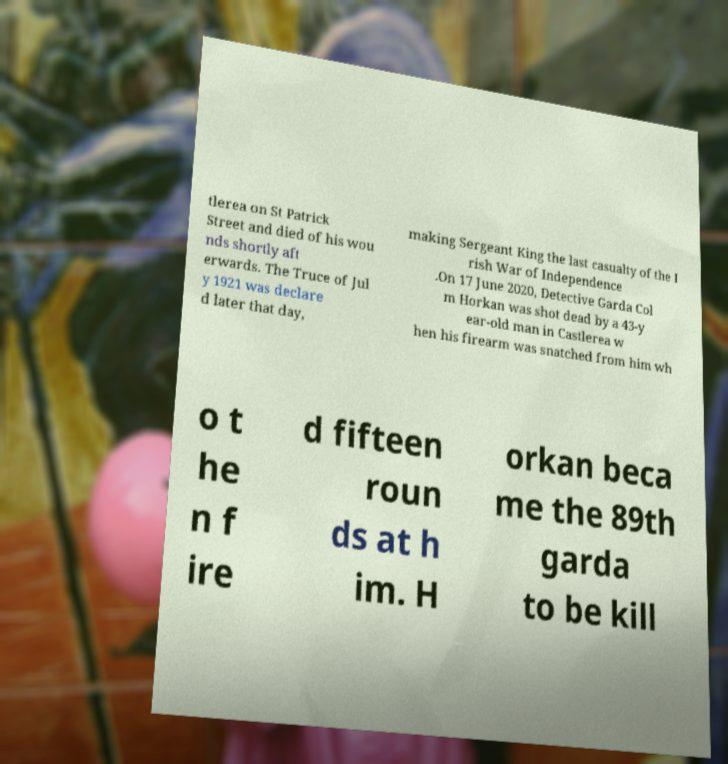Can you accurately transcribe the text from the provided image for me? tlerea on St Patrick Street and died of his wou nds shortly aft erwards. The Truce of Jul y 1921 was declare d later that day, making Sergeant King the last casualty of the I rish War of Independence .On 17 June 2020, Detective Garda Col m Horkan was shot dead by a 43-y ear-old man in Castlerea w hen his firearm was snatched from him wh o t he n f ire d fifteen roun ds at h im. H orkan beca me the 89th garda to be kill 